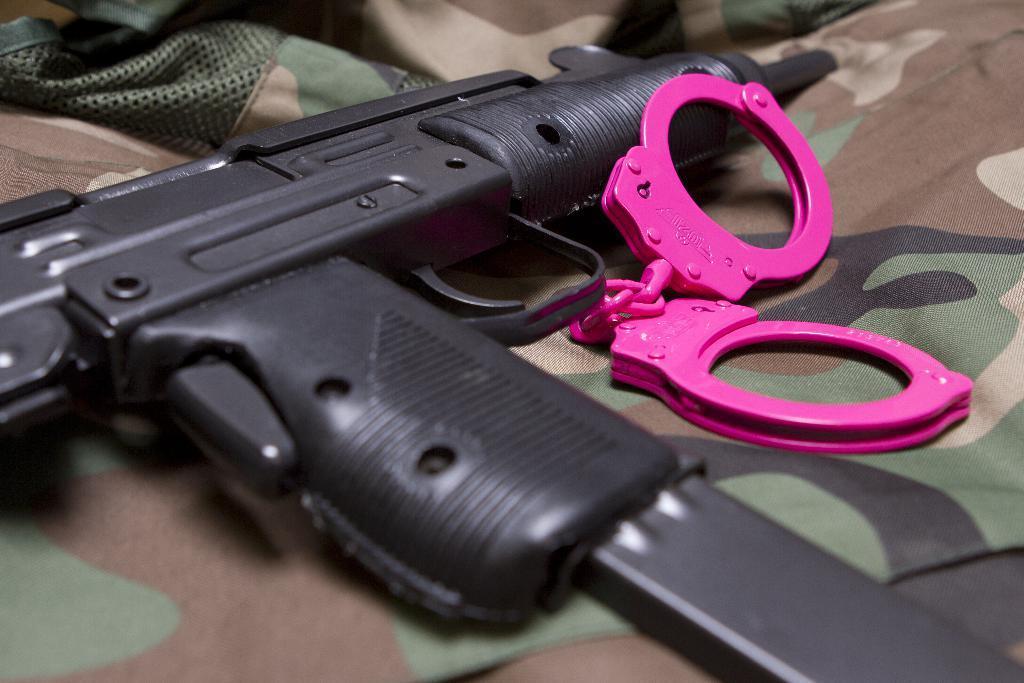Can you describe this image briefly? In this image there is a gun and some other objects on the camouflage cloth. 